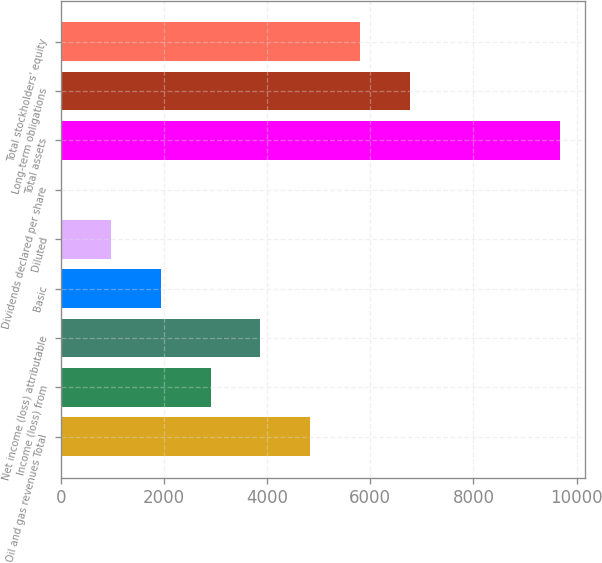Convert chart. <chart><loc_0><loc_0><loc_500><loc_500><bar_chart><fcel>Oil and gas revenues Total<fcel>Income (loss) from<fcel>Net income (loss) attributable<fcel>Basic<fcel>Diluted<fcel>Dividends declared per share<fcel>Total assets<fcel>Long-term obligations<fcel>Total stockholders' equity<nl><fcel>4839.58<fcel>2903.78<fcel>3871.68<fcel>1935.88<fcel>967.98<fcel>0.08<fcel>9679.1<fcel>6775.38<fcel>5807.48<nl></chart> 